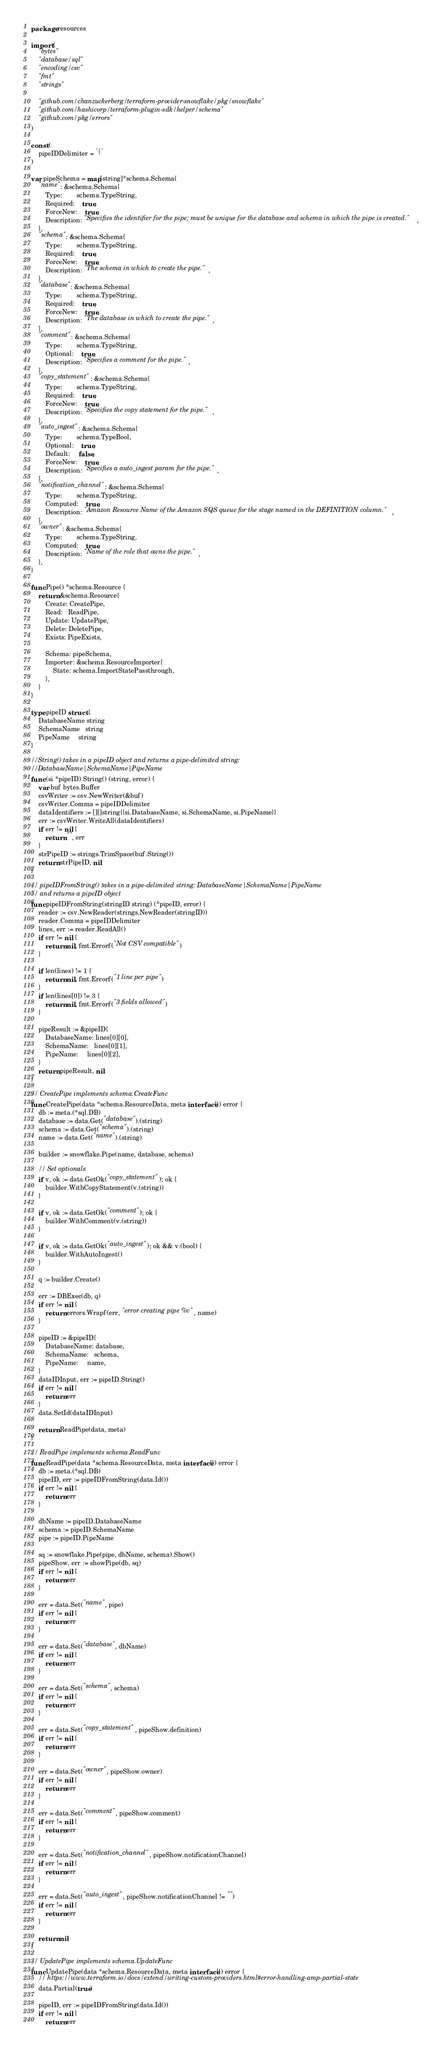Convert code to text. <code><loc_0><loc_0><loc_500><loc_500><_Go_>package resources

import (
	"bytes"
	"database/sql"
	"encoding/csv"
	"fmt"
	"strings"

	"github.com/chanzuckerberg/terraform-provider-snowflake/pkg/snowflake"
	"github.com/hashicorp/terraform-plugin-sdk/helper/schema"
	"github.com/pkg/errors"
)

const (
	pipeIDDelimiter = '|'
)

var pipeSchema = map[string]*schema.Schema{
	"name": &schema.Schema{
		Type:        schema.TypeString,
		Required:    true,
		ForceNew:    true,
		Description: "Specifies the identifier for the pipe; must be unique for the database and schema in which the pipe is created.",
	},
	"schema": &schema.Schema{
		Type:        schema.TypeString,
		Required:    true,
		ForceNew:    true,
		Description: "The schema in which to create the pipe.",
	},
	"database": &schema.Schema{
		Type:        schema.TypeString,
		Required:    true,
		ForceNew:    true,
		Description: "The database in which to create the pipe.",
	},
	"comment": &schema.Schema{
		Type:        schema.TypeString,
		Optional:    true,
		Description: "Specifies a comment for the pipe.",
	},
	"copy_statement": &schema.Schema{
		Type:        schema.TypeString,
		Required:    true,
		ForceNew:    true,
		Description: "Specifies the copy statement for the pipe.",
	},
	"auto_ingest": &schema.Schema{
		Type:        schema.TypeBool,
		Optional:    true,
		Default:     false,
		ForceNew:    true,
		Description: "Specifies a auto_ingest param for the pipe.",
	},
	"notification_channel": &schema.Schema{
		Type:        schema.TypeString,
		Computed:    true,
		Description: "Amazon Resource Name of the Amazon SQS queue for the stage named in the DEFINITION column.",
	},
	"owner": &schema.Schema{
		Type:        schema.TypeString,
		Computed:    true,
		Description: "Name of the role that owns the pipe.",
	},
}

func Pipe() *schema.Resource {
	return &schema.Resource{
		Create: CreatePipe,
		Read:   ReadPipe,
		Update: UpdatePipe,
		Delete: DeletePipe,
		Exists: PipeExists,

		Schema: pipeSchema,
		Importer: &schema.ResourceImporter{
			State: schema.ImportStatePassthrough,
		},
	}
}

type pipeID struct {
	DatabaseName string
	SchemaName   string
	PipeName     string
}

//String() takes in a pipeID object and returns a pipe-delimited string:
//DatabaseName|SchemaName|PipeName
func (si *pipeID) String() (string, error) {
	var buf bytes.Buffer
	csvWriter := csv.NewWriter(&buf)
	csvWriter.Comma = pipeIDDelimiter
	dataIdentifiers := [][]string{{si.DatabaseName, si.SchemaName, si.PipeName}}
	err := csvWriter.WriteAll(dataIdentifiers)
	if err != nil {
		return "", err
	}
	strPipeID := strings.TrimSpace(buf.String())
	return strPipeID, nil
}

// pipeIDFromString() takes in a pipe-delimited string: DatabaseName|SchemaName|PipeName
// and returns a pipeID object
func pipeIDFromString(stringID string) (*pipeID, error) {
	reader := csv.NewReader(strings.NewReader(stringID))
	reader.Comma = pipeIDDelimiter
	lines, err := reader.ReadAll()
	if err != nil {
		return nil, fmt.Errorf("Not CSV compatible")
	}

	if len(lines) != 1 {
		return nil, fmt.Errorf("1 line per pipe")
	}
	if len(lines[0]) != 3 {
		return nil, fmt.Errorf("3 fields allowed")
	}

	pipeResult := &pipeID{
		DatabaseName: lines[0][0],
		SchemaName:   lines[0][1],
		PipeName:     lines[0][2],
	}
	return pipeResult, nil
}

// CreatePipe implements schema.CreateFunc
func CreatePipe(data *schema.ResourceData, meta interface{}) error {
	db := meta.(*sql.DB)
	database := data.Get("database").(string)
	schema := data.Get("schema").(string)
	name := data.Get("name").(string)

	builder := snowflake.Pipe(name, database, schema)

	// Set optionals
	if v, ok := data.GetOk("copy_statement"); ok {
		builder.WithCopyStatement(v.(string))
	}

	if v, ok := data.GetOk("comment"); ok {
		builder.WithComment(v.(string))
	}

	if v, ok := data.GetOk("auto_ingest"); ok && v.(bool) {
		builder.WithAutoIngest()
	}

	q := builder.Create()

	err := DBExec(db, q)
	if err != nil {
		return errors.Wrapf(err, "error creating pipe %v", name)
	}

	pipeID := &pipeID{
		DatabaseName: database,
		SchemaName:   schema,
		PipeName:     name,
	}
	dataIDInput, err := pipeID.String()
	if err != nil {
		return err
	}
	data.SetId(dataIDInput)

	return ReadPipe(data, meta)
}

// ReadPipe implements schema.ReadFunc
func ReadPipe(data *schema.ResourceData, meta interface{}) error {
	db := meta.(*sql.DB)
	pipeID, err := pipeIDFromString(data.Id())
	if err != nil {
		return err
	}

	dbName := pipeID.DatabaseName
	schema := pipeID.SchemaName
	pipe := pipeID.PipeName

	sq := snowflake.Pipe(pipe, dbName, schema).Show()
	pipeShow, err := showPipe(db, sq)
	if err != nil {
		return err
	}

	err = data.Set("name", pipe)
	if err != nil {
		return err
	}

	err = data.Set("database", dbName)
	if err != nil {
		return err
	}

	err = data.Set("schema", schema)
	if err != nil {
		return err
	}

	err = data.Set("copy_statement", pipeShow.definition)
	if err != nil {
		return err
	}

	err = data.Set("owner", pipeShow.owner)
	if err != nil {
		return err
	}

	err = data.Set("comment", pipeShow.comment)
	if err != nil {
		return err
	}

	err = data.Set("notification_channel", pipeShow.notificationChannel)
	if err != nil {
		return err
	}

	err = data.Set("auto_ingest", pipeShow.notificationChannel != "")
	if err != nil {
		return err
	}

	return nil
}

// UpdatePipe implements schema.UpdateFunc
func UpdatePipe(data *schema.ResourceData, meta interface{}) error {
	// https://www.terraform.io/docs/extend/writing-custom-providers.html#error-handling-amp-partial-state
	data.Partial(true)

	pipeID, err := pipeIDFromString(data.Id())
	if err != nil {
		return err</code> 